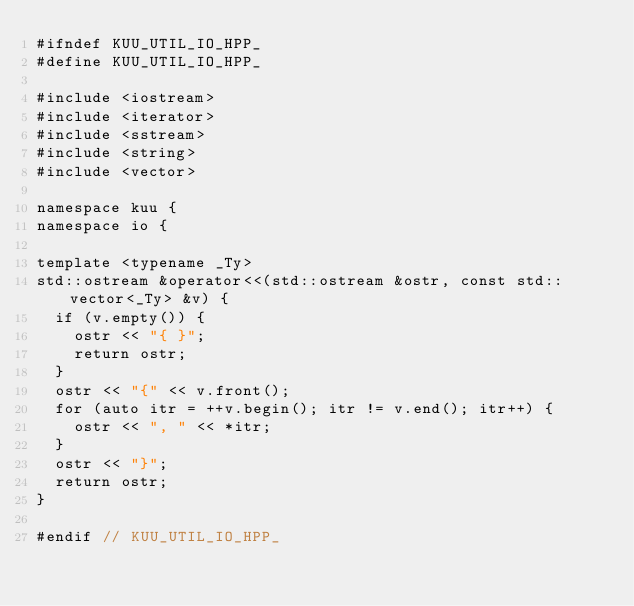<code> <loc_0><loc_0><loc_500><loc_500><_C++_>#ifndef KUU_UTIL_IO_HPP_
#define KUU_UTIL_IO_HPP_

#include <iostream>
#include <iterator>
#include <sstream>
#include <string>
#include <vector>

namespace kuu {
namespace io {

template <typename _Ty>
std::ostream &operator<<(std::ostream &ostr, const std::vector<_Ty> &v) {
  if (v.empty()) {
    ostr << "{ }";
    return ostr;
  }
  ostr << "{" << v.front();
  for (auto itr = ++v.begin(); itr != v.end(); itr++) {
    ostr << ", " << *itr;
  }
  ostr << "}";
  return ostr;
}

#endif // KUU_UTIL_IO_HPP_</code> 